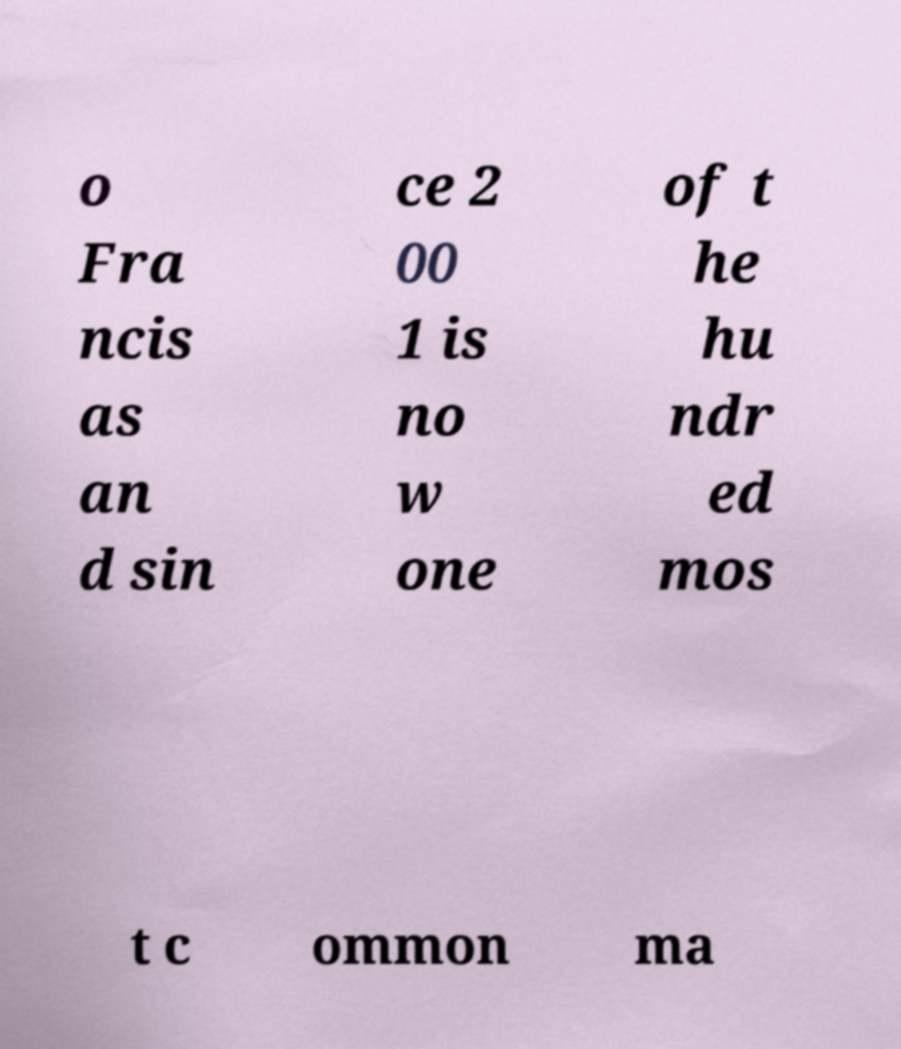Can you read and provide the text displayed in the image?This photo seems to have some interesting text. Can you extract and type it out for me? o Fra ncis as an d sin ce 2 00 1 is no w one of t he hu ndr ed mos t c ommon ma 